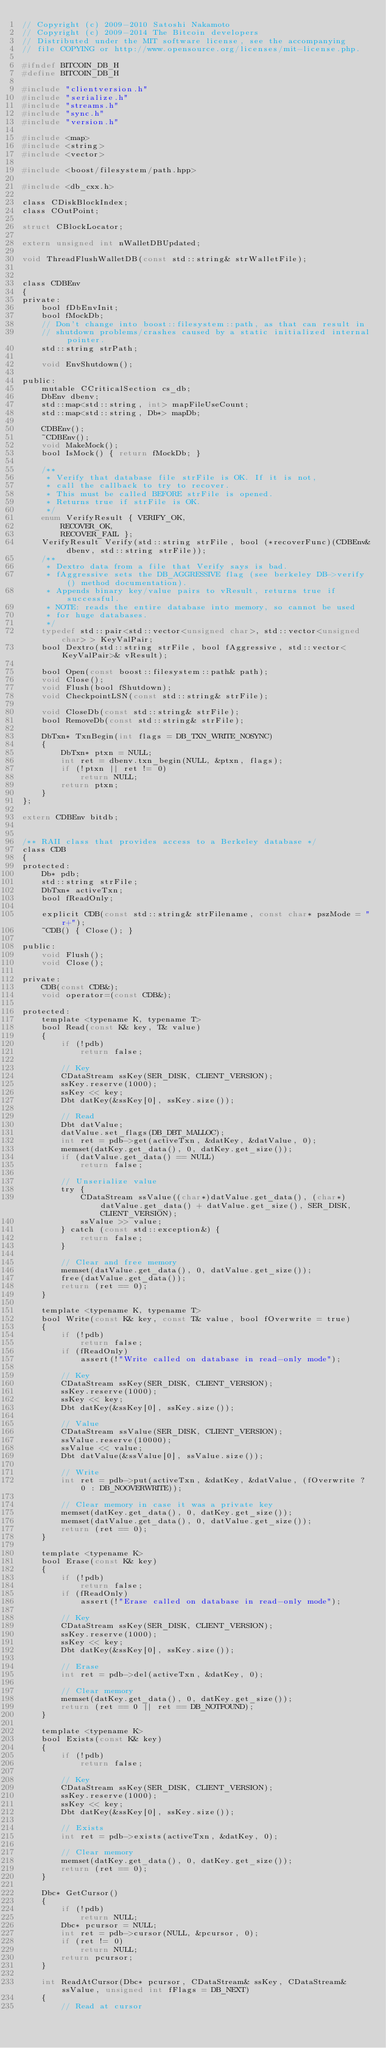Convert code to text. <code><loc_0><loc_0><loc_500><loc_500><_C_>// Copyright (c) 2009-2010 Satoshi Nakamoto
// Copyright (c) 2009-2014 The Bitcoin developers
// Distributed under the MIT software license, see the accompanying
// file COPYING or http://www.opensource.org/licenses/mit-license.php.

#ifndef BITCOIN_DB_H
#define BITCOIN_DB_H

#include "clientversion.h"
#include "serialize.h"
#include "streams.h"
#include "sync.h"
#include "version.h"

#include <map>
#include <string>
#include <vector>

#include <boost/filesystem/path.hpp>

#include <db_cxx.h>

class CDiskBlockIndex;
class COutPoint;

struct CBlockLocator;

extern unsigned int nWalletDBUpdated;

void ThreadFlushWalletDB(const std::string& strWalletFile);


class CDBEnv
{
private:
    bool fDbEnvInit;
    bool fMockDb;
    // Don't change into boost::filesystem::path, as that can result in
    // shutdown problems/crashes caused by a static initialized internal pointer.
    std::string strPath;

    void EnvShutdown();

public:
    mutable CCriticalSection cs_db;
    DbEnv dbenv;
    std::map<std::string, int> mapFileUseCount;
    std::map<std::string, Db*> mapDb;

    CDBEnv();
    ~CDBEnv();
    void MakeMock();
    bool IsMock() { return fMockDb; }

    /**
     * Verify that database file strFile is OK. If it is not,
     * call the callback to try to recover.
     * This must be called BEFORE strFile is opened.
     * Returns true if strFile is OK.
     */
    enum VerifyResult { VERIFY_OK,
        RECOVER_OK,
        RECOVER_FAIL };
    VerifyResult Verify(std::string strFile, bool (*recoverFunc)(CDBEnv& dbenv, std::string strFile));
    /**
     * Dextro data from a file that Verify says is bad.
     * fAggressive sets the DB_AGGRESSIVE flag (see berkeley DB->verify() method documentation).
     * Appends binary key/value pairs to vResult, returns true if successful.
     * NOTE: reads the entire database into memory, so cannot be used
     * for huge databases.
     */
    typedef std::pair<std::vector<unsigned char>, std::vector<unsigned char> > KeyValPair;
    bool Dextro(std::string strFile, bool fAggressive, std::vector<KeyValPair>& vResult);

    bool Open(const boost::filesystem::path& path);
    void Close();
    void Flush(bool fShutdown);
    void CheckpointLSN(const std::string& strFile);

    void CloseDb(const std::string& strFile);
    bool RemoveDb(const std::string& strFile);

    DbTxn* TxnBegin(int flags = DB_TXN_WRITE_NOSYNC)
    {
        DbTxn* ptxn = NULL;
        int ret = dbenv.txn_begin(NULL, &ptxn, flags);
        if (!ptxn || ret != 0)
            return NULL;
        return ptxn;
    }
};

extern CDBEnv bitdb;


/** RAII class that provides access to a Berkeley database */
class CDB
{
protected:
    Db* pdb;
    std::string strFile;
    DbTxn* activeTxn;
    bool fReadOnly;

    explicit CDB(const std::string& strFilename, const char* pszMode = "r+");
    ~CDB() { Close(); }

public:
    void Flush();
    void Close();

private:
    CDB(const CDB&);
    void operator=(const CDB&);

protected:
    template <typename K, typename T>
    bool Read(const K& key, T& value)
    {
        if (!pdb)
            return false;

        // Key
        CDataStream ssKey(SER_DISK, CLIENT_VERSION);
        ssKey.reserve(1000);
        ssKey << key;
        Dbt datKey(&ssKey[0], ssKey.size());

        // Read
        Dbt datValue;
        datValue.set_flags(DB_DBT_MALLOC);
        int ret = pdb->get(activeTxn, &datKey, &datValue, 0);
        memset(datKey.get_data(), 0, datKey.get_size());
        if (datValue.get_data() == NULL)
            return false;

        // Unserialize value
        try {
            CDataStream ssValue((char*)datValue.get_data(), (char*)datValue.get_data() + datValue.get_size(), SER_DISK, CLIENT_VERSION);
            ssValue >> value;
        } catch (const std::exception&) {
            return false;
        }

        // Clear and free memory
        memset(datValue.get_data(), 0, datValue.get_size());
        free(datValue.get_data());
        return (ret == 0);
    }

    template <typename K, typename T>
    bool Write(const K& key, const T& value, bool fOverwrite = true)
    {
        if (!pdb)
            return false;
        if (fReadOnly)
            assert(!"Write called on database in read-only mode");

        // Key
        CDataStream ssKey(SER_DISK, CLIENT_VERSION);
        ssKey.reserve(1000);
        ssKey << key;
        Dbt datKey(&ssKey[0], ssKey.size());

        // Value
        CDataStream ssValue(SER_DISK, CLIENT_VERSION);
        ssValue.reserve(10000);
        ssValue << value;
        Dbt datValue(&ssValue[0], ssValue.size());

        // Write
        int ret = pdb->put(activeTxn, &datKey, &datValue, (fOverwrite ? 0 : DB_NOOVERWRITE));

        // Clear memory in case it was a private key
        memset(datKey.get_data(), 0, datKey.get_size());
        memset(datValue.get_data(), 0, datValue.get_size());
        return (ret == 0);
    }

    template <typename K>
    bool Erase(const K& key)
    {
        if (!pdb)
            return false;
        if (fReadOnly)
            assert(!"Erase called on database in read-only mode");

        // Key
        CDataStream ssKey(SER_DISK, CLIENT_VERSION);
        ssKey.reserve(1000);
        ssKey << key;
        Dbt datKey(&ssKey[0], ssKey.size());

        // Erase
        int ret = pdb->del(activeTxn, &datKey, 0);

        // Clear memory
        memset(datKey.get_data(), 0, datKey.get_size());
        return (ret == 0 || ret == DB_NOTFOUND);
    }

    template <typename K>
    bool Exists(const K& key)
    {
        if (!pdb)
            return false;

        // Key
        CDataStream ssKey(SER_DISK, CLIENT_VERSION);
        ssKey.reserve(1000);
        ssKey << key;
        Dbt datKey(&ssKey[0], ssKey.size());

        // Exists
        int ret = pdb->exists(activeTxn, &datKey, 0);

        // Clear memory
        memset(datKey.get_data(), 0, datKey.get_size());
        return (ret == 0);
    }

    Dbc* GetCursor()
    {
        if (!pdb)
            return NULL;
        Dbc* pcursor = NULL;
        int ret = pdb->cursor(NULL, &pcursor, 0);
        if (ret != 0)
            return NULL;
        return pcursor;
    }

    int ReadAtCursor(Dbc* pcursor, CDataStream& ssKey, CDataStream& ssValue, unsigned int fFlags = DB_NEXT)
    {
        // Read at cursor</code> 